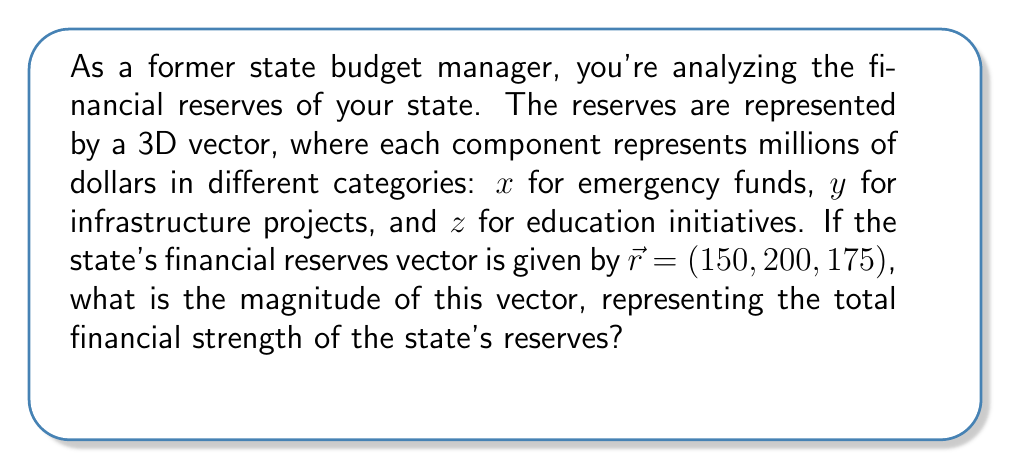Could you help me with this problem? To find the magnitude of the state's financial reserves vector, we need to calculate the length of the vector $\vec{r} = (150, 200, 175)$. The magnitude of a 3D vector is given by the square root of the sum of the squares of its components.

Let's follow these steps:

1) The formula for the magnitude of a 3D vector $\vec{r} = (x, y, z)$ is:

   $||\vec{r}|| = \sqrt{x^2 + y^2 + z^2}$

2) Substituting our values:

   $||\vec{r}|| = \sqrt{150^2 + 200^2 + 175^2}$

3) Calculate the squares:

   $||\vec{r}|| = \sqrt{22,500 + 40,000 + 30,625}$

4) Sum the values under the square root:

   $||\vec{r}|| = \sqrt{93,125}$

5) Calculate the square root:

   $||\vec{r}|| = 305.16$ (rounded to two decimal places)

Therefore, the magnitude of the state's financial reserves vector is approximately 305.16 million dollars.
Answer: $305.16$ million dollars 